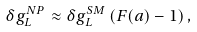Convert formula to latex. <formula><loc_0><loc_0><loc_500><loc_500>\delta g ^ { N P } _ { L } \approx \delta g _ { L } ^ { S M } \left ( F ( a ) - 1 \right ) ,</formula> 